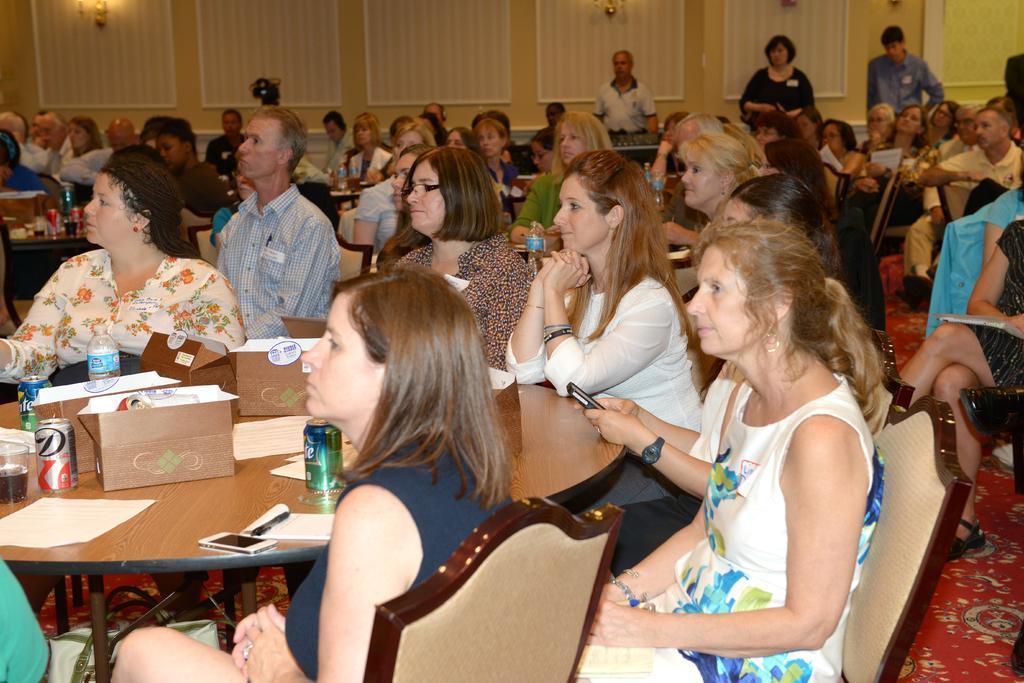Could you give a brief overview of what you see in this image? There is a big hall in which there are so many people. There is a table on which we have box,drink,bottle,paper,mobile. There is a woman sitting on a chair. A woman is wearing a watch to her left hand while holding a mobile with both the hands. A man is sitting on chair and looking forward. At the background we have a wall with a design on it. And there is a red carpet on the floor. A woman is wearing a spectacles. 